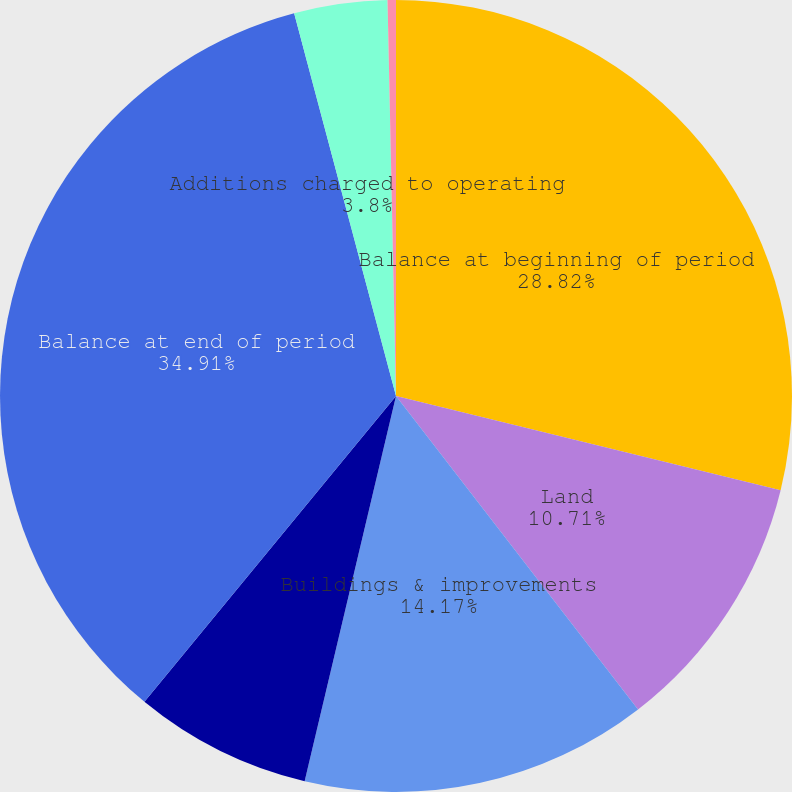Convert chart. <chart><loc_0><loc_0><loc_500><loc_500><pie_chart><fcel>Balance at beginning of period<fcel>Land<fcel>Buildings & improvements<fcel>Less Assets sold and<fcel>Balance at end of period<fcel>Additions charged to operating<fcel>Less Accumulated depreciation<nl><fcel>28.82%<fcel>10.71%<fcel>14.17%<fcel>7.25%<fcel>34.9%<fcel>3.8%<fcel>0.34%<nl></chart> 